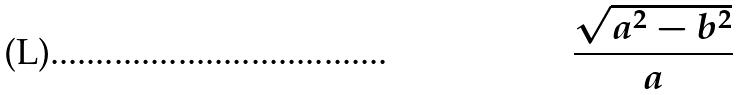<formula> <loc_0><loc_0><loc_500><loc_500>\frac { \sqrt { a ^ { 2 } - b ^ { 2 } } } { a }</formula> 